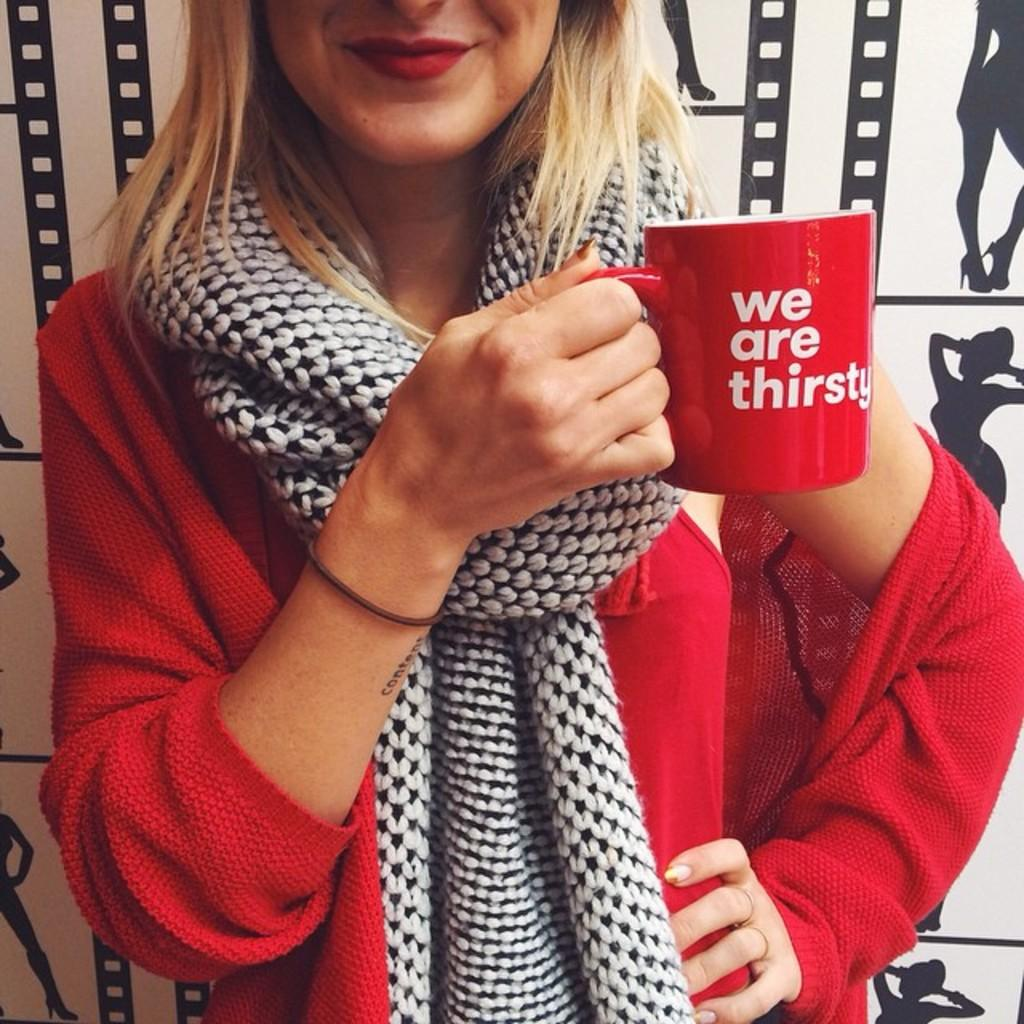What is present in the image? There is a woman in the image. What is the woman holding in her hand? The woman is holding a cup. Which hand is the woman using to hold the cup? The cup is in the woman's right hand. What type of tomatoes can be seen in the woman's hair in the image? There are no tomatoes present in the image, and the woman's hair is not mentioned in the provided facts. What type of gold jewelry is the woman wearing in the image? There is no mention of any jewelry, including gold, in the provided facts. 